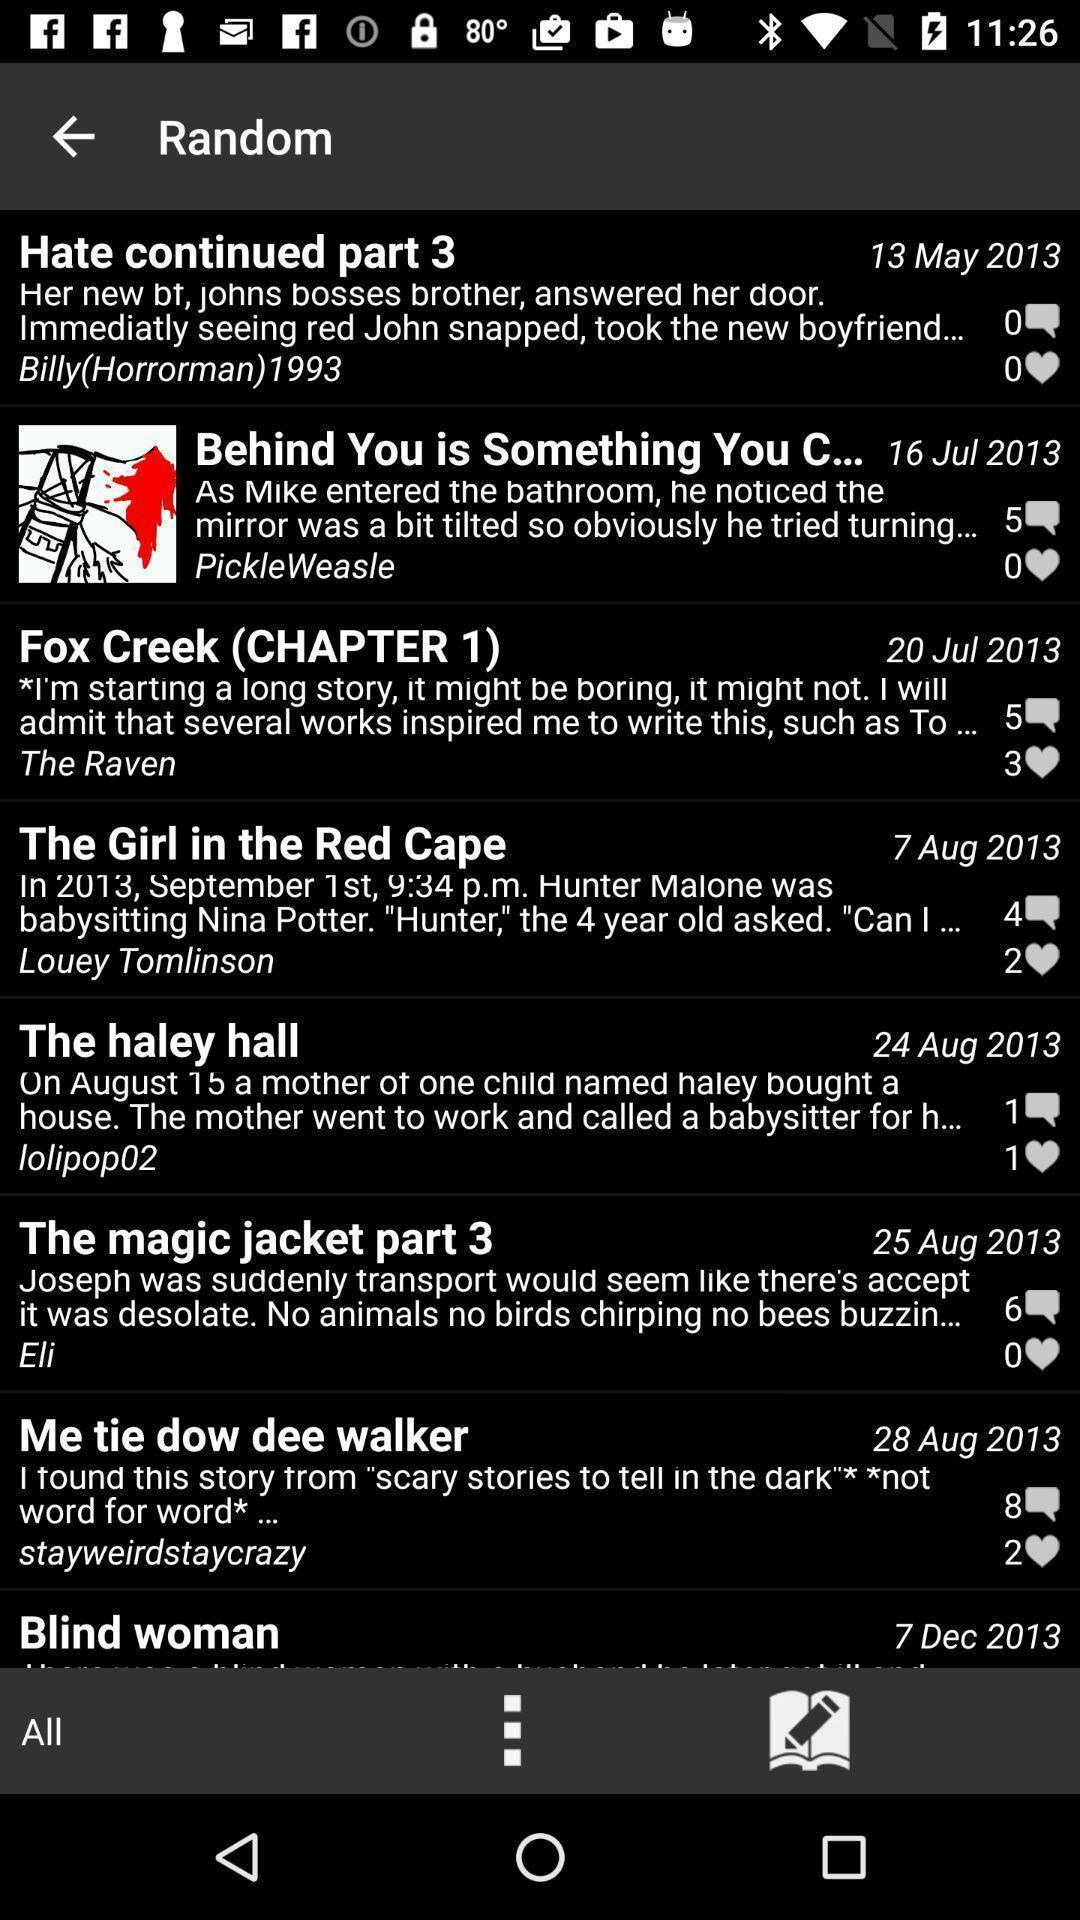What details can you identify in this image? Page showing list of different messages. 